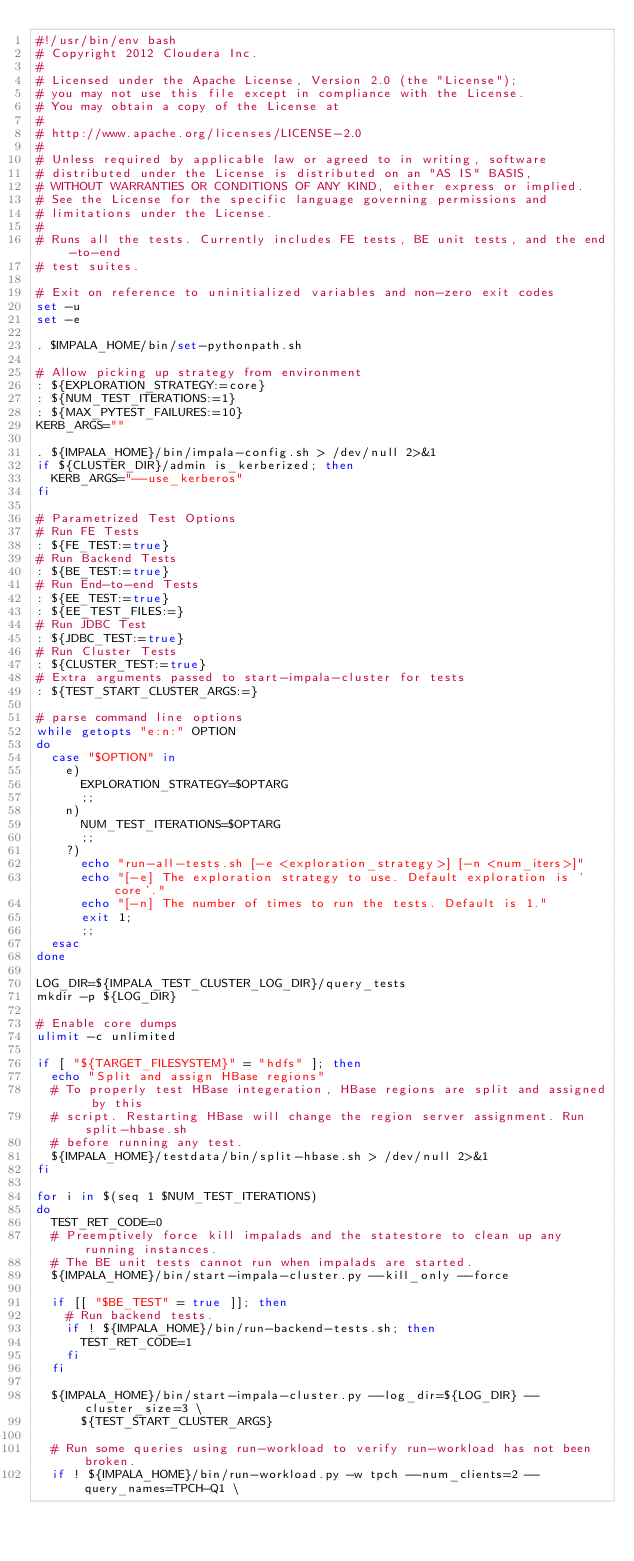Convert code to text. <code><loc_0><loc_0><loc_500><loc_500><_Bash_>#!/usr/bin/env bash
# Copyright 2012 Cloudera Inc.
#
# Licensed under the Apache License, Version 2.0 (the "License");
# you may not use this file except in compliance with the License.
# You may obtain a copy of the License at
#
# http://www.apache.org/licenses/LICENSE-2.0
#
# Unless required by applicable law or agreed to in writing, software
# distributed under the License is distributed on an "AS IS" BASIS,
# WITHOUT WARRANTIES OR CONDITIONS OF ANY KIND, either express or implied.
# See the License for the specific language governing permissions and
# limitations under the License.
#
# Runs all the tests. Currently includes FE tests, BE unit tests, and the end-to-end
# test suites.

# Exit on reference to uninitialized variables and non-zero exit codes
set -u
set -e

. $IMPALA_HOME/bin/set-pythonpath.sh

# Allow picking up strategy from environment
: ${EXPLORATION_STRATEGY:=core}
: ${NUM_TEST_ITERATIONS:=1}
: ${MAX_PYTEST_FAILURES:=10}
KERB_ARGS=""

. ${IMPALA_HOME}/bin/impala-config.sh > /dev/null 2>&1
if ${CLUSTER_DIR}/admin is_kerberized; then
  KERB_ARGS="--use_kerberos"
fi

# Parametrized Test Options
# Run FE Tests
: ${FE_TEST:=true}
# Run Backend Tests
: ${BE_TEST:=true}
# Run End-to-end Tests
: ${EE_TEST:=true}
: ${EE_TEST_FILES:=}
# Run JDBC Test
: ${JDBC_TEST:=true}
# Run Cluster Tests
: ${CLUSTER_TEST:=true}
# Extra arguments passed to start-impala-cluster for tests
: ${TEST_START_CLUSTER_ARGS:=}

# parse command line options
while getopts "e:n:" OPTION
do
  case "$OPTION" in
    e)
      EXPLORATION_STRATEGY=$OPTARG
      ;;
    n)
      NUM_TEST_ITERATIONS=$OPTARG
      ;;
    ?)
      echo "run-all-tests.sh [-e <exploration_strategy>] [-n <num_iters>]"
      echo "[-e] The exploration strategy to use. Default exploration is 'core'."
      echo "[-n] The number of times to run the tests. Default is 1."
      exit 1;
      ;;
  esac
done

LOG_DIR=${IMPALA_TEST_CLUSTER_LOG_DIR}/query_tests
mkdir -p ${LOG_DIR}

# Enable core dumps
ulimit -c unlimited

if [ "${TARGET_FILESYSTEM}" = "hdfs" ]; then
  echo "Split and assign HBase regions"
  # To properly test HBase integeration, HBase regions are split and assigned by this
  # script. Restarting HBase will change the region server assignment. Run split-hbase.sh
  # before running any test.
  ${IMPALA_HOME}/testdata/bin/split-hbase.sh > /dev/null 2>&1
fi

for i in $(seq 1 $NUM_TEST_ITERATIONS)
do
  TEST_RET_CODE=0
  # Preemptively force kill impalads and the statestore to clean up any running instances.
  # The BE unit tests cannot run when impalads are started.
  ${IMPALA_HOME}/bin/start-impala-cluster.py --kill_only --force

  if [[ "$BE_TEST" = true ]]; then
    # Run backend tests.
    if ! ${IMPALA_HOME}/bin/run-backend-tests.sh; then
      TEST_RET_CODE=1
    fi
  fi

  ${IMPALA_HOME}/bin/start-impala-cluster.py --log_dir=${LOG_DIR} --cluster_size=3 \
      ${TEST_START_CLUSTER_ARGS}

  # Run some queries using run-workload to verify run-workload has not been broken.
  if ! ${IMPALA_HOME}/bin/run-workload.py -w tpch --num_clients=2 --query_names=TPCH-Q1 \</code> 